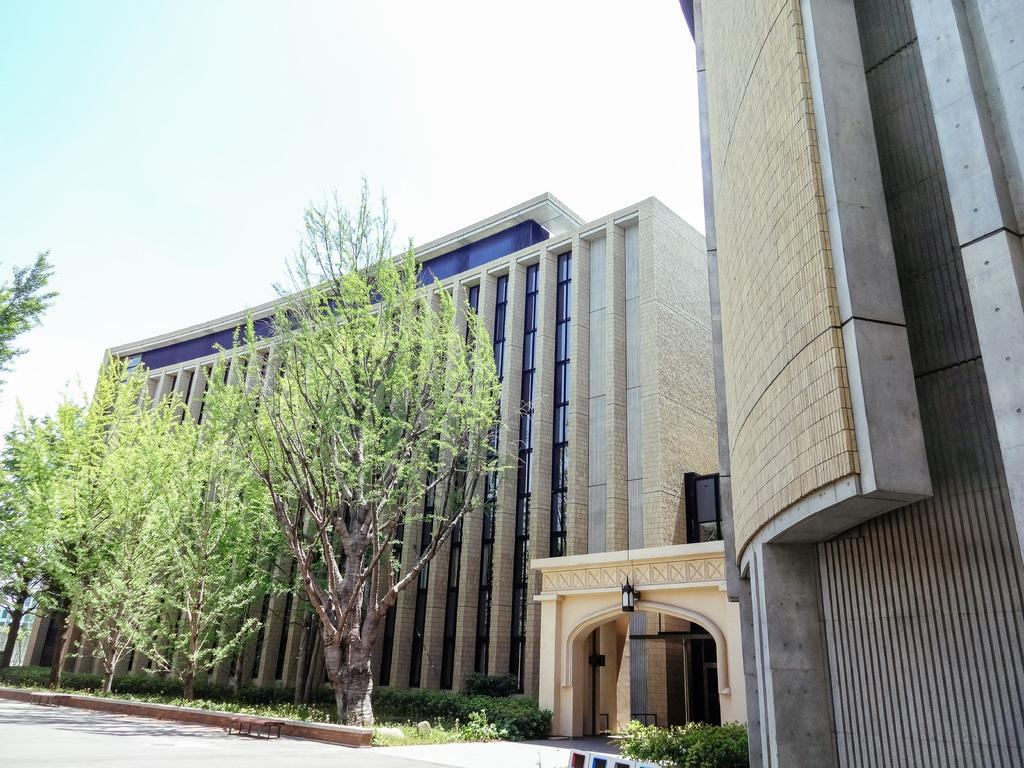What type of structures can be seen in the image? There are buildings in the image. What else can be found along a path in the image? There are plants on a path in the image. What type of vegetation is present in the image? There are trees in the image. How can one enter the building in the image? There is a gateway to a building in the image. What is visible behind the building in the image? The sky is visible behind the building in the image. Reasoning: Let'g: Let's think step by step in order to produce the conversation. We start by identifying the main subjects and objects in the image based on the provided facts. We then formulate questions that focus on the location and characteristics of these subjects and objects, ensuring that each question can be answered definitively with the information given. We avoid yes/no questions and ensure that the language is simple and clear. Absurd Question/Answer: What type of bun is being used to hold up the gateway in the image? There is no bun present in the image; the gateway is supported by a structure or post. How does the development of the buildings in the image affect the surrounding environment? The provided facts do not mention any development or its effects on the environment, so we cannot answer this question. What type of bun is being used to hold up the gateway in the image? There is no bun present in the image; the gateway is supported by a structure or post. 